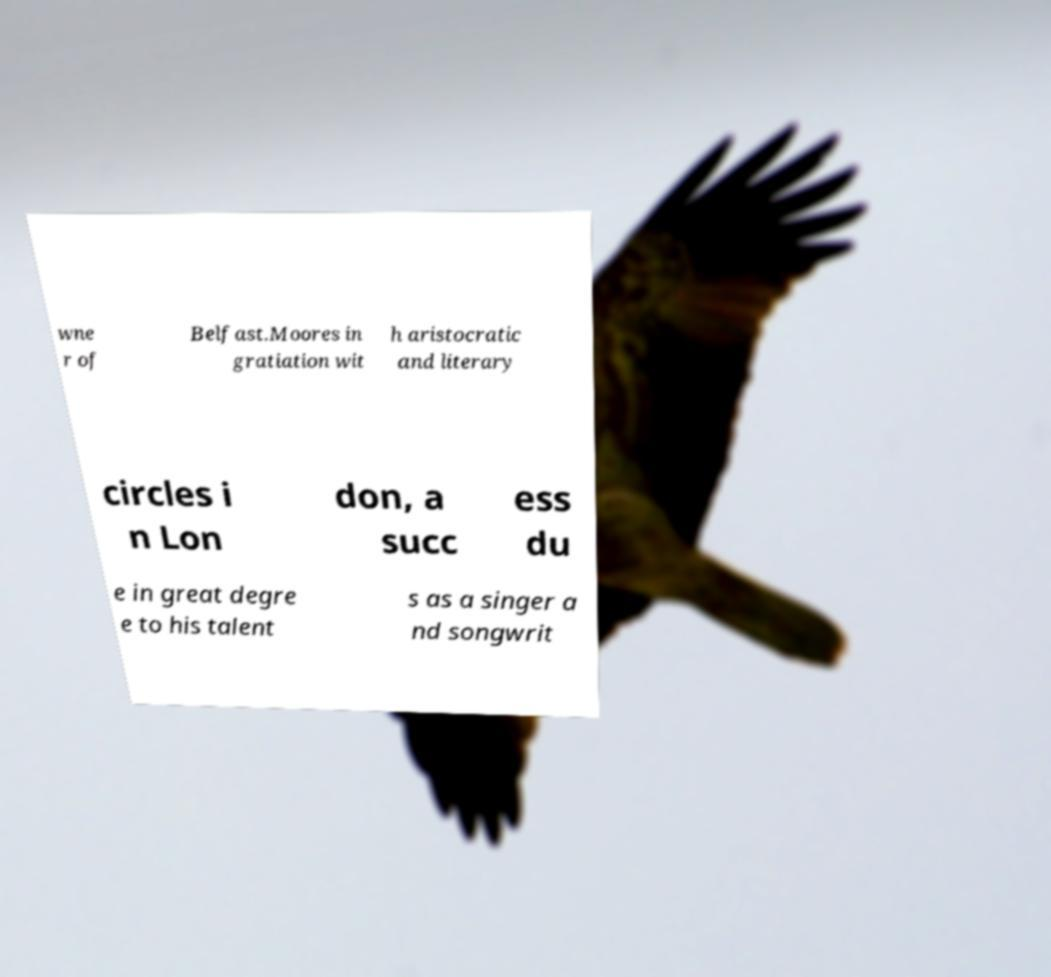Can you accurately transcribe the text from the provided image for me? wne r of Belfast.Moores in gratiation wit h aristocratic and literary circles i n Lon don, a succ ess du e in great degre e to his talent s as a singer a nd songwrit 